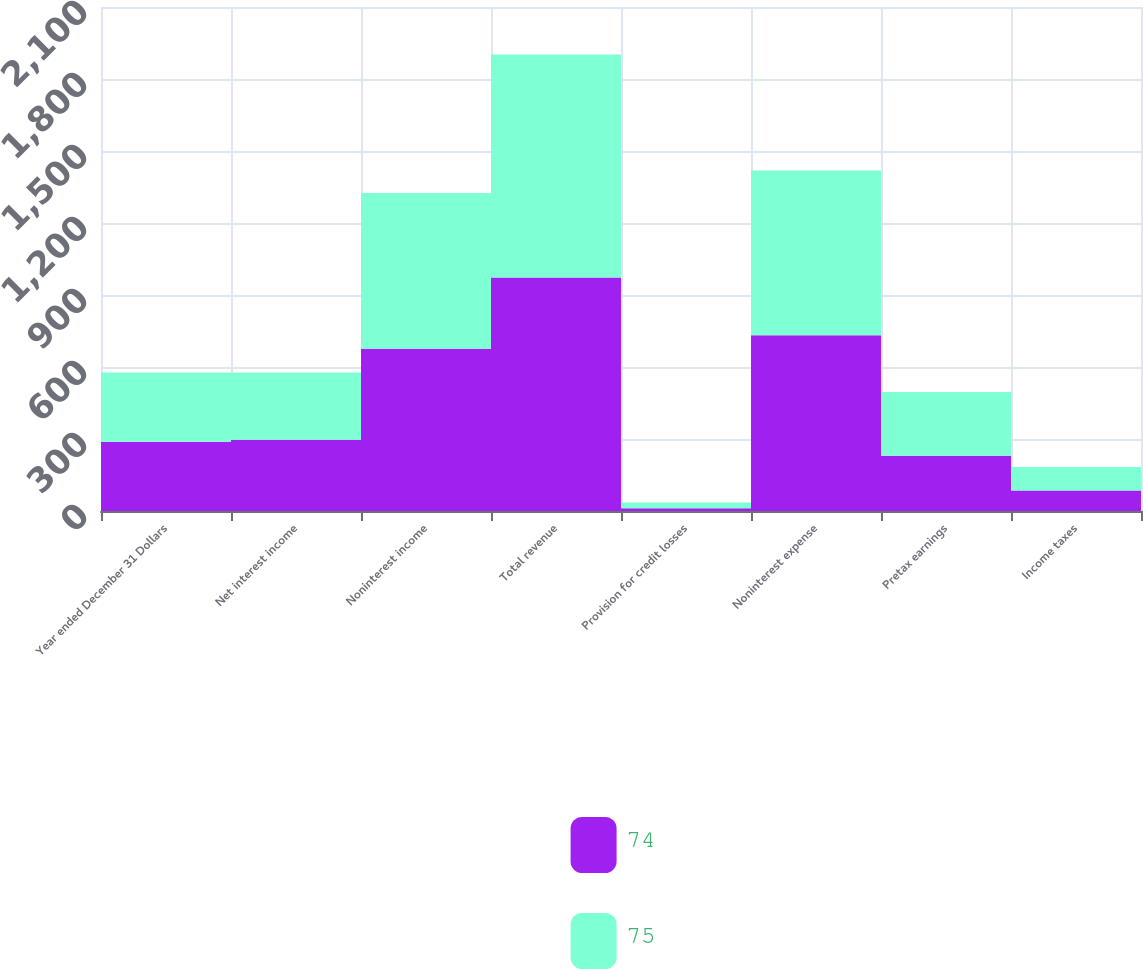<chart> <loc_0><loc_0><loc_500><loc_500><stacked_bar_chart><ecel><fcel>Year ended December 31 Dollars<fcel>Net interest income<fcel>Noninterest income<fcel>Total revenue<fcel>Provision for credit losses<fcel>Noninterest expense<fcel>Pretax earnings<fcel>Income taxes<nl><fcel>74<fcel>288.5<fcel>297<fcel>676<fcel>973<fcel>11<fcel>732<fcel>230<fcel>85<nl><fcel>75<fcel>288.5<fcel>280<fcel>649<fcel>929<fcel>24<fcel>687<fcel>266<fcel>98<nl></chart> 